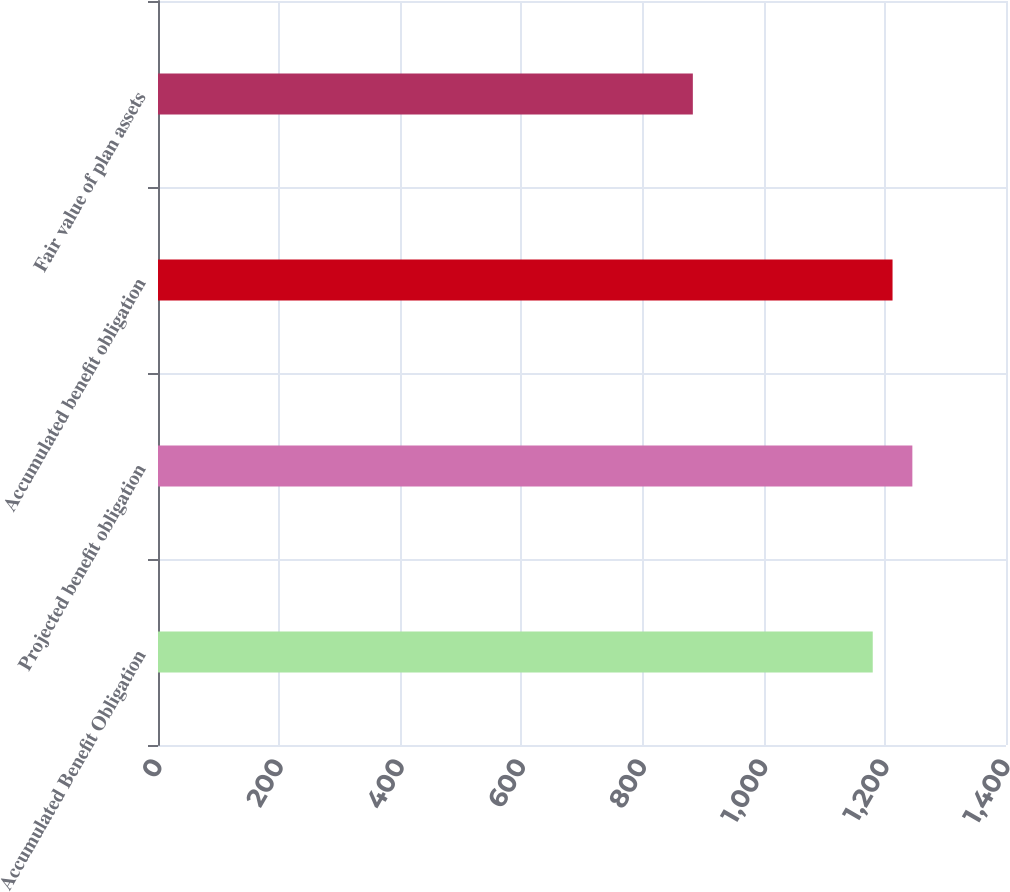Convert chart. <chart><loc_0><loc_0><loc_500><loc_500><bar_chart><fcel>Accumulated Benefit Obligation<fcel>Projected benefit obligation<fcel>Accumulated benefit obligation<fcel>Fair value of plan assets<nl><fcel>1180<fcel>1245.4<fcel>1212.7<fcel>883<nl></chart> 